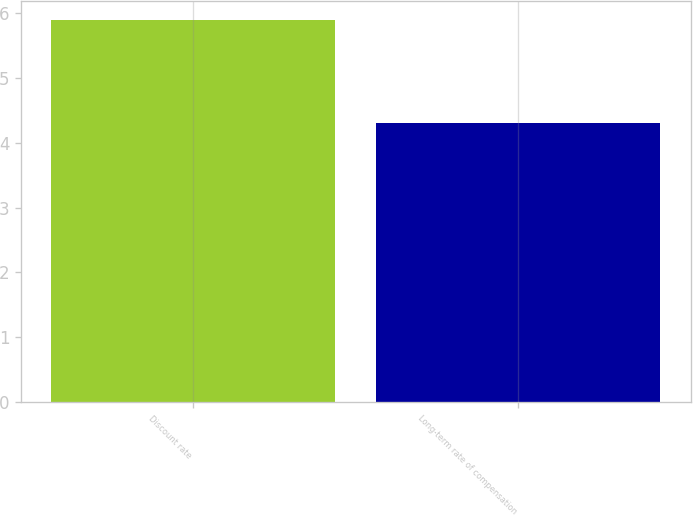Convert chart. <chart><loc_0><loc_0><loc_500><loc_500><bar_chart><fcel>Discount rate<fcel>Long-term rate of compensation<nl><fcel>5.9<fcel>4.3<nl></chart> 